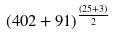Convert formula to latex. <formula><loc_0><loc_0><loc_500><loc_500>( 4 0 2 + 9 1 ) ^ { \frac { ( 2 5 + 3 ) } { 2 } }</formula> 